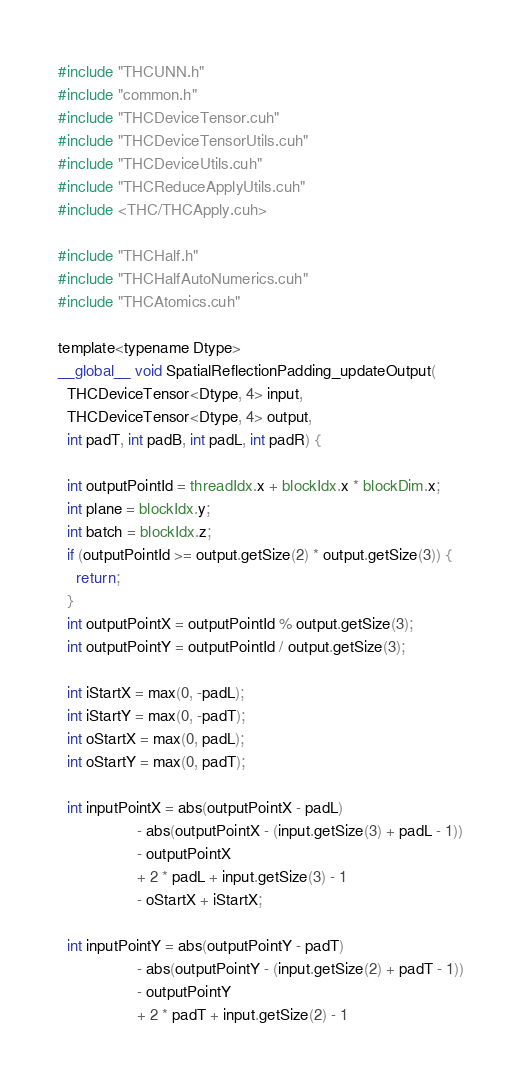Convert code to text. <code><loc_0><loc_0><loc_500><loc_500><_Cuda_>#include "THCUNN.h"
#include "common.h"
#include "THCDeviceTensor.cuh"
#include "THCDeviceTensorUtils.cuh"
#include "THCDeviceUtils.cuh"
#include "THCReduceApplyUtils.cuh"
#include <THC/THCApply.cuh>

#include "THCHalf.h"
#include "THCHalfAutoNumerics.cuh"
#include "THCAtomics.cuh"

template<typename Dtype>
__global__ void SpatialReflectionPadding_updateOutput(
  THCDeviceTensor<Dtype, 4> input,
  THCDeviceTensor<Dtype, 4> output,
  int padT, int padB, int padL, int padR) {

  int outputPointId = threadIdx.x + blockIdx.x * blockDim.x;
  int plane = blockIdx.y;
  int batch = blockIdx.z;
  if (outputPointId >= output.getSize(2) * output.getSize(3)) {
    return;
  }
  int outputPointX = outputPointId % output.getSize(3);
  int outputPointY = outputPointId / output.getSize(3);

  int iStartX = max(0, -padL);
  int iStartY = max(0, -padT);
  int oStartX = max(0, padL);
  int oStartY = max(0, padT);

  int inputPointX = abs(outputPointX - padL)
                  - abs(outputPointX - (input.getSize(3) + padL - 1))
                  - outputPointX
                  + 2 * padL + input.getSize(3) - 1
                  - oStartX + iStartX;

  int inputPointY = abs(outputPointY - padT)
                  - abs(outputPointY - (input.getSize(2) + padT - 1))
                  - outputPointY
                  + 2 * padT + input.getSize(2) - 1</code> 